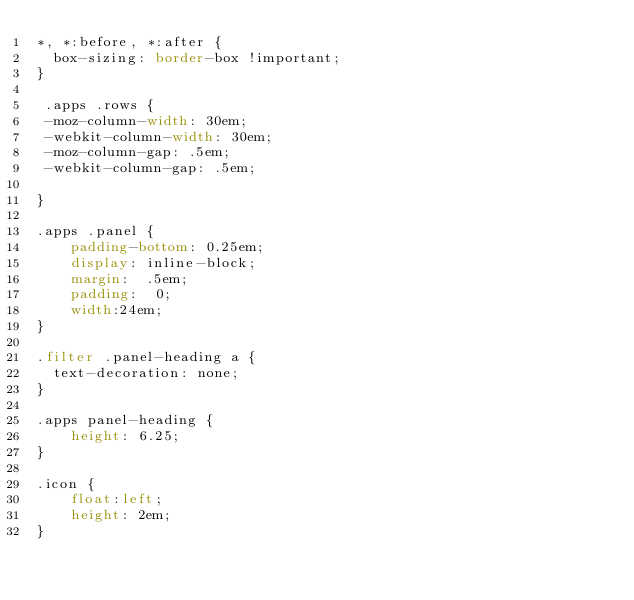Convert code to text. <code><loc_0><loc_0><loc_500><loc_500><_CSS_>*, *:before, *:after {
  box-sizing: border-box !important;
}

 .apps .rows {
 -moz-column-width: 30em;
 -webkit-column-width: 30em;
 -moz-column-gap: .5em;
 -webkit-column-gap: .5em;

}

.apps .panel {
    padding-bottom: 0.25em;
    display: inline-block;
    margin:  .5em;
    padding:  0;
    width:24em;
}

.filter .panel-heading a {
  text-decoration: none;
}

.apps panel-heading {
    height: 6.25;
}

.icon {
    float:left;
    height: 2em;
}
</code> 